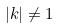<formula> <loc_0><loc_0><loc_500><loc_500>| k | \ne 1</formula> 